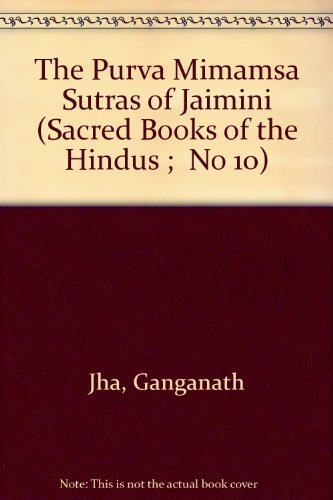Who wrote this book?
Answer the question using a single word or phrase. Ganganath Jha What is the title of this book? The Purva Mimamsa Sutras of Jaimini (Sacred Books of the Hindus ;  No 10) What is the genre of this book? Religion & Spirituality Is this book related to Religion & Spirituality? Yes Is this book related to Crafts, Hobbies & Home? No 